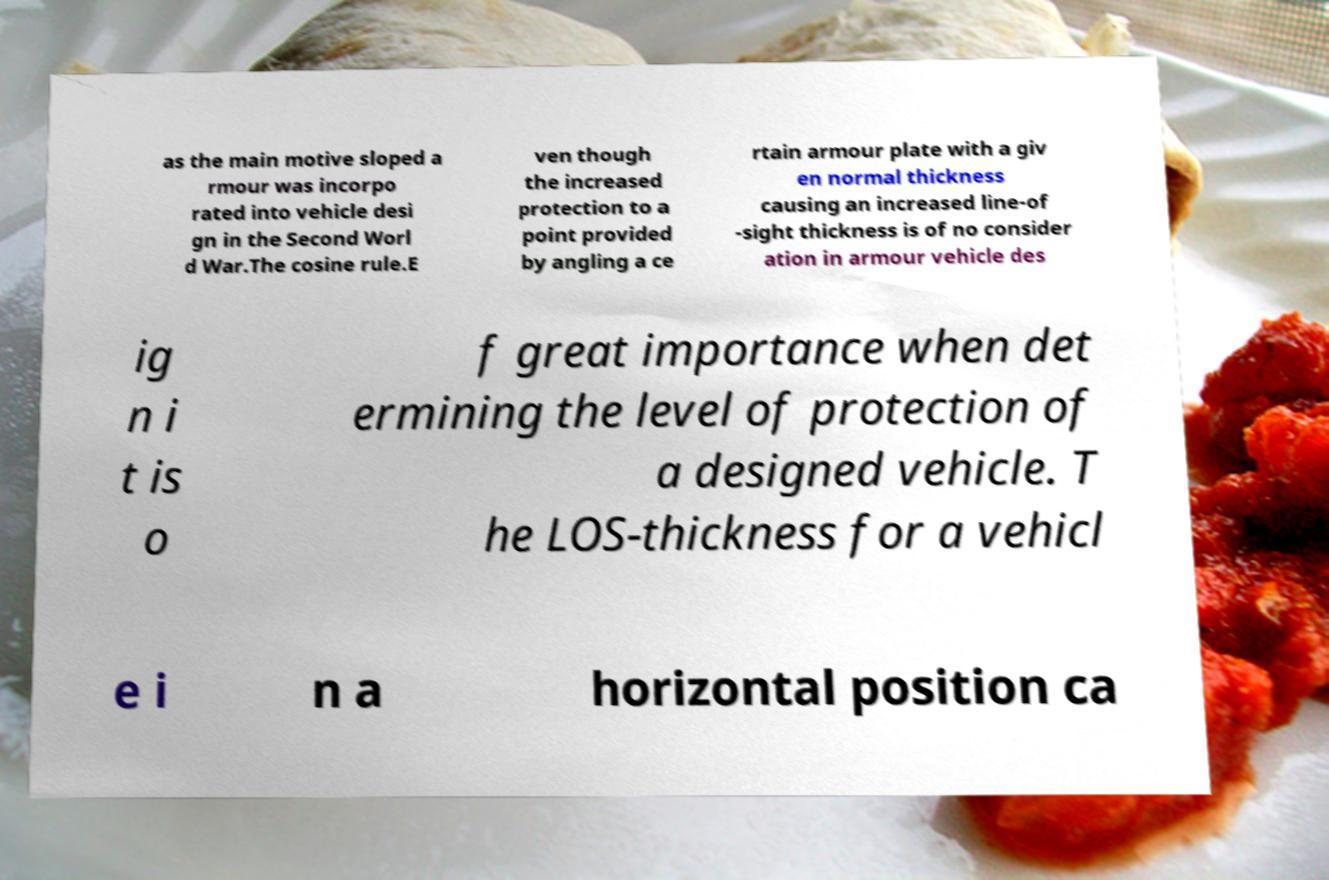Could you assist in decoding the text presented in this image and type it out clearly? as the main motive sloped a rmour was incorpo rated into vehicle desi gn in the Second Worl d War.The cosine rule.E ven though the increased protection to a point provided by angling a ce rtain armour plate with a giv en normal thickness causing an increased line-of -sight thickness is of no consider ation in armour vehicle des ig n i t is o f great importance when det ermining the level of protection of a designed vehicle. T he LOS-thickness for a vehicl e i n a horizontal position ca 